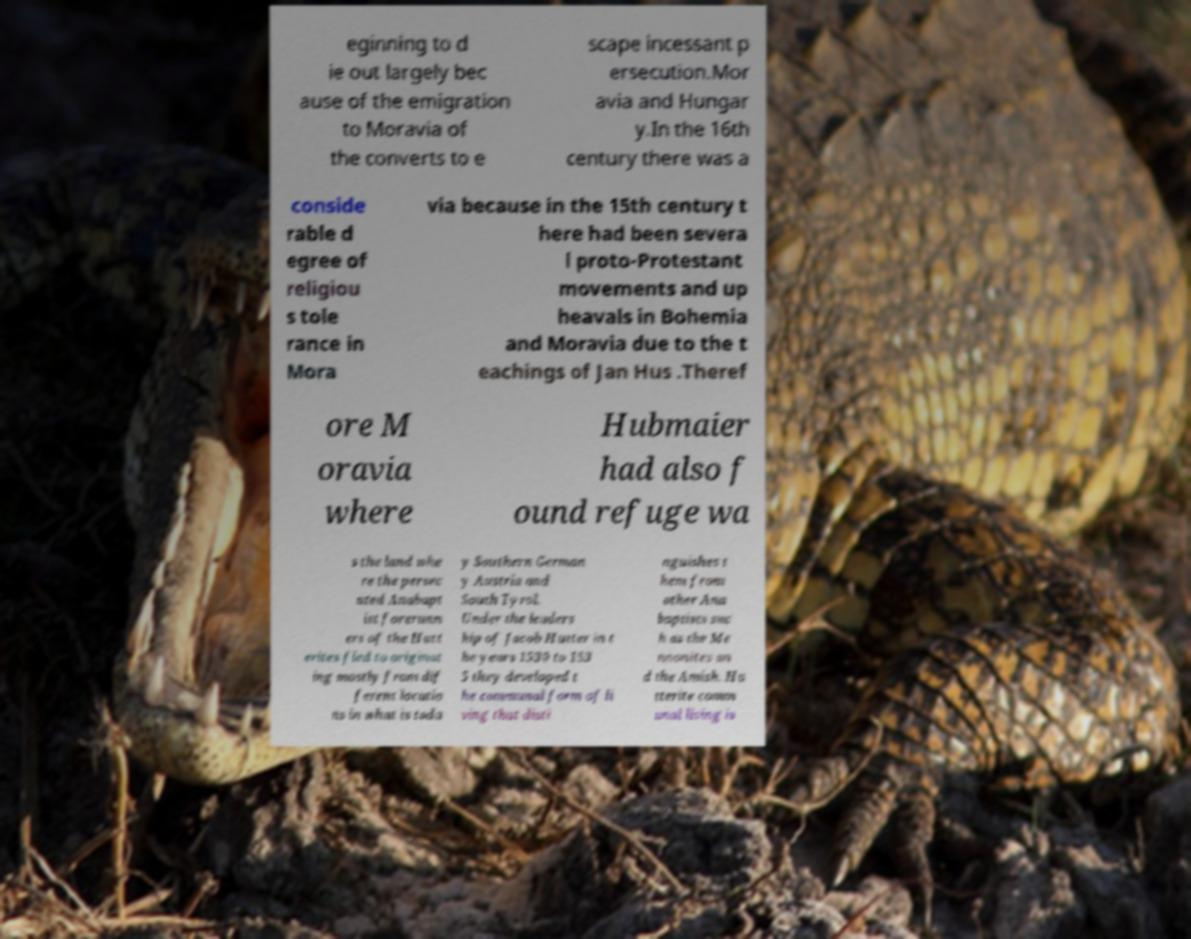There's text embedded in this image that I need extracted. Can you transcribe it verbatim? eginning to d ie out largely bec ause of the emigration to Moravia of the converts to e scape incessant p ersecution.Mor avia and Hungar y.In the 16th century there was a conside rable d egree of religiou s tole rance in Mora via because in the 15th century t here had been severa l proto-Protestant movements and up heavals in Bohemia and Moravia due to the t eachings of Jan Hus .Theref ore M oravia where Hubmaier had also f ound refuge wa s the land whe re the persec uted Anabapt ist forerunn ers of the Hutt erites fled to originat ing mostly from dif ferent locatio ns in what is toda y Southern German y Austria and South Tyrol. Under the leaders hip of Jacob Hutter in t he years 1530 to 153 5 they developed t he communal form of li ving that disti nguishes t hem from other Ana baptists suc h as the Me nnonites an d the Amish. Hu tterite comm unal living is 